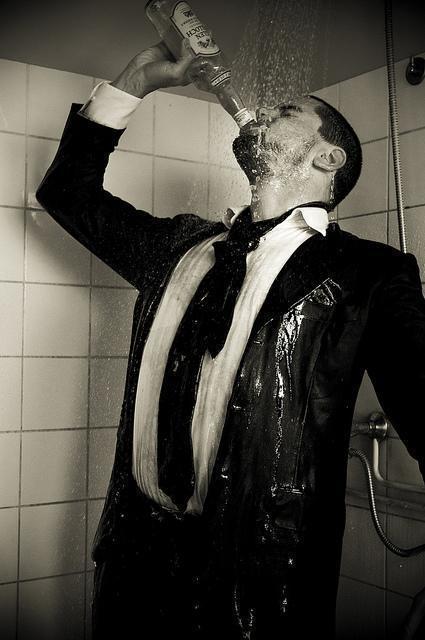What single item is most out of place?
Select the accurate answer and provide explanation: 'Answer: answer
Rationale: rationale.'
Options: Man, beverage, suit, shower. Answer: shower.
Rationale: The man is fully dressed and standing in a shower where his clothes are getting wet. 